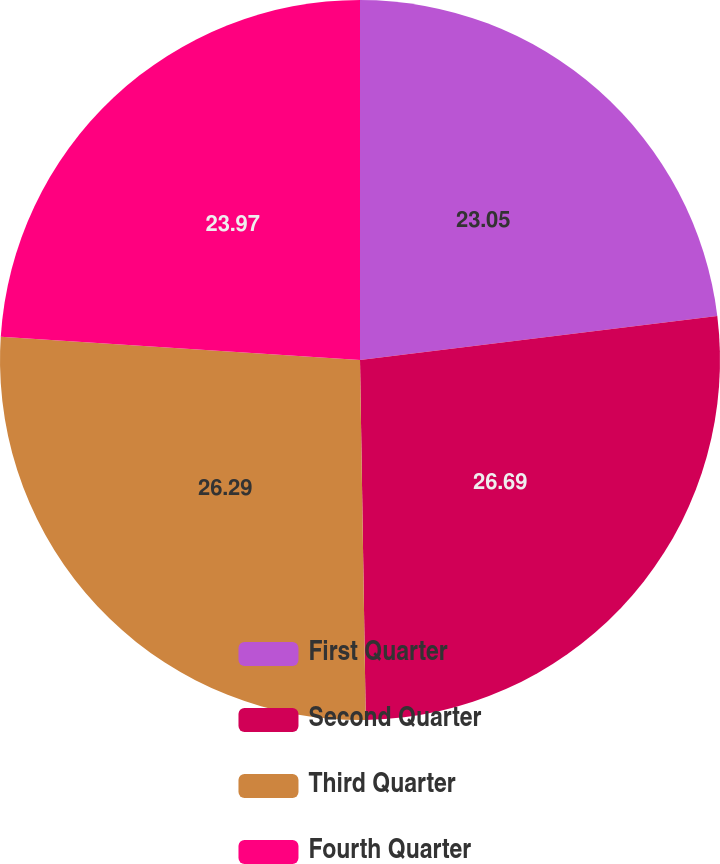Convert chart. <chart><loc_0><loc_0><loc_500><loc_500><pie_chart><fcel>First Quarter<fcel>Second Quarter<fcel>Third Quarter<fcel>Fourth Quarter<nl><fcel>23.05%<fcel>26.7%<fcel>26.29%<fcel>23.97%<nl></chart> 